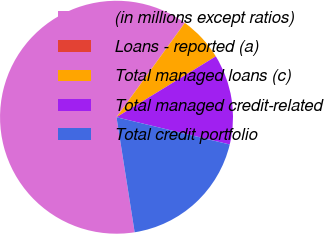Convert chart. <chart><loc_0><loc_0><loc_500><loc_500><pie_chart><fcel>(in millions except ratios)<fcel>Loans - reported (a)<fcel>Total managed loans (c)<fcel>Total managed credit-related<fcel>Total credit portfolio<nl><fcel>62.45%<fcel>0.02%<fcel>6.27%<fcel>12.51%<fcel>18.75%<nl></chart> 